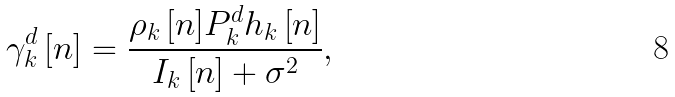<formula> <loc_0><loc_0><loc_500><loc_500>\gamma ^ { d } _ { k } \left [ n \right ] = \frac { { \rho _ { k } \left [ n \right ] } P _ { k } ^ { d } { h _ { k } \left [ n \right ] } } { I _ { k } \left [ n \right ] + \sigma ^ { 2 } } ,</formula> 